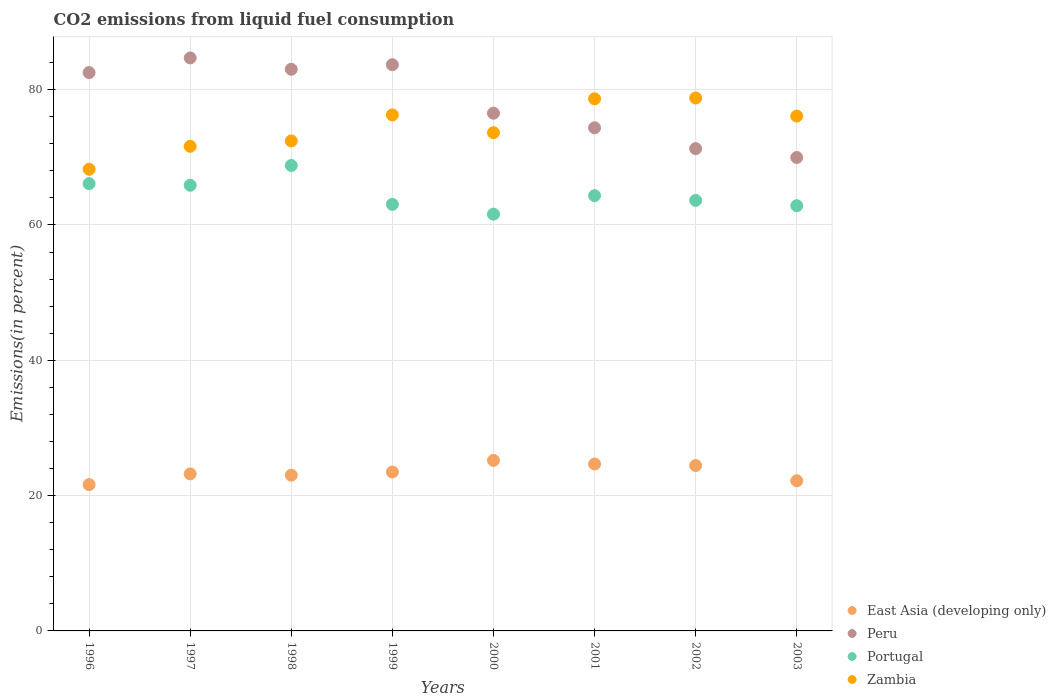What is the total CO2 emitted in Zambia in 1997?
Make the answer very short. 71.63. Across all years, what is the maximum total CO2 emitted in Zambia?
Give a very brief answer. 78.77. Across all years, what is the minimum total CO2 emitted in East Asia (developing only)?
Make the answer very short. 21.63. In which year was the total CO2 emitted in Zambia maximum?
Provide a short and direct response. 2002. What is the total total CO2 emitted in Zambia in the graph?
Your answer should be compact. 595.71. What is the difference between the total CO2 emitted in Peru in 1996 and that in 2001?
Ensure brevity in your answer.  8.16. What is the difference between the total CO2 emitted in Portugal in 1998 and the total CO2 emitted in Zambia in 1996?
Give a very brief answer. 0.56. What is the average total CO2 emitted in Peru per year?
Ensure brevity in your answer.  78.26. In the year 2000, what is the difference between the total CO2 emitted in East Asia (developing only) and total CO2 emitted in Portugal?
Ensure brevity in your answer.  -36.39. In how many years, is the total CO2 emitted in Peru greater than 24 %?
Make the answer very short. 8. What is the ratio of the total CO2 emitted in East Asia (developing only) in 1996 to that in 2003?
Ensure brevity in your answer.  0.97. Is the total CO2 emitted in Peru in 1996 less than that in 1998?
Your answer should be compact. Yes. What is the difference between the highest and the second highest total CO2 emitted in Portugal?
Offer a very short reply. 2.68. What is the difference between the highest and the lowest total CO2 emitted in East Asia (developing only)?
Give a very brief answer. 3.58. What is the difference between two consecutive major ticks on the Y-axis?
Give a very brief answer. 20. Does the graph contain any zero values?
Ensure brevity in your answer.  No. Does the graph contain grids?
Ensure brevity in your answer.  Yes. How are the legend labels stacked?
Offer a very short reply. Vertical. What is the title of the graph?
Offer a terse response. CO2 emissions from liquid fuel consumption. Does "Bhutan" appear as one of the legend labels in the graph?
Provide a succinct answer. No. What is the label or title of the X-axis?
Make the answer very short. Years. What is the label or title of the Y-axis?
Keep it short and to the point. Emissions(in percent). What is the Emissions(in percent) of East Asia (developing only) in 1996?
Ensure brevity in your answer.  21.63. What is the Emissions(in percent) in Peru in 1996?
Offer a very short reply. 82.53. What is the Emissions(in percent) in Portugal in 1996?
Offer a terse response. 66.11. What is the Emissions(in percent) of Zambia in 1996?
Provide a succinct answer. 68.24. What is the Emissions(in percent) in East Asia (developing only) in 1997?
Your response must be concise. 23.21. What is the Emissions(in percent) of Peru in 1997?
Provide a short and direct response. 84.69. What is the Emissions(in percent) of Portugal in 1997?
Your answer should be compact. 65.87. What is the Emissions(in percent) in Zambia in 1997?
Provide a short and direct response. 71.63. What is the Emissions(in percent) of East Asia (developing only) in 1998?
Your response must be concise. 23.02. What is the Emissions(in percent) of Peru in 1998?
Provide a short and direct response. 83.01. What is the Emissions(in percent) in Portugal in 1998?
Your response must be concise. 68.79. What is the Emissions(in percent) of Zambia in 1998?
Ensure brevity in your answer.  72.42. What is the Emissions(in percent) of East Asia (developing only) in 1999?
Offer a terse response. 23.49. What is the Emissions(in percent) in Peru in 1999?
Provide a short and direct response. 83.69. What is the Emissions(in percent) in Portugal in 1999?
Ensure brevity in your answer.  63.05. What is the Emissions(in percent) in Zambia in 1999?
Your response must be concise. 76.27. What is the Emissions(in percent) of East Asia (developing only) in 2000?
Give a very brief answer. 25.21. What is the Emissions(in percent) in Peru in 2000?
Offer a terse response. 76.52. What is the Emissions(in percent) of Portugal in 2000?
Offer a very short reply. 61.6. What is the Emissions(in percent) of Zambia in 2000?
Your response must be concise. 73.64. What is the Emissions(in percent) of East Asia (developing only) in 2001?
Keep it short and to the point. 24.67. What is the Emissions(in percent) in Peru in 2001?
Give a very brief answer. 74.37. What is the Emissions(in percent) of Portugal in 2001?
Keep it short and to the point. 64.34. What is the Emissions(in percent) of Zambia in 2001?
Ensure brevity in your answer.  78.65. What is the Emissions(in percent) of East Asia (developing only) in 2002?
Your response must be concise. 24.45. What is the Emissions(in percent) of Peru in 2002?
Ensure brevity in your answer.  71.28. What is the Emissions(in percent) in Portugal in 2002?
Your response must be concise. 63.63. What is the Emissions(in percent) in Zambia in 2002?
Your response must be concise. 78.77. What is the Emissions(in percent) in East Asia (developing only) in 2003?
Make the answer very short. 22.19. What is the Emissions(in percent) of Peru in 2003?
Give a very brief answer. 69.97. What is the Emissions(in percent) in Portugal in 2003?
Give a very brief answer. 62.85. What is the Emissions(in percent) of Zambia in 2003?
Keep it short and to the point. 76.09. Across all years, what is the maximum Emissions(in percent) of East Asia (developing only)?
Provide a short and direct response. 25.21. Across all years, what is the maximum Emissions(in percent) of Peru?
Your response must be concise. 84.69. Across all years, what is the maximum Emissions(in percent) of Portugal?
Provide a succinct answer. 68.79. Across all years, what is the maximum Emissions(in percent) of Zambia?
Offer a very short reply. 78.77. Across all years, what is the minimum Emissions(in percent) in East Asia (developing only)?
Your answer should be compact. 21.63. Across all years, what is the minimum Emissions(in percent) in Peru?
Give a very brief answer. 69.97. Across all years, what is the minimum Emissions(in percent) of Portugal?
Give a very brief answer. 61.6. Across all years, what is the minimum Emissions(in percent) in Zambia?
Provide a short and direct response. 68.24. What is the total Emissions(in percent) of East Asia (developing only) in the graph?
Make the answer very short. 187.87. What is the total Emissions(in percent) in Peru in the graph?
Offer a terse response. 626.06. What is the total Emissions(in percent) of Portugal in the graph?
Offer a terse response. 516.23. What is the total Emissions(in percent) in Zambia in the graph?
Offer a terse response. 595.71. What is the difference between the Emissions(in percent) of East Asia (developing only) in 1996 and that in 1997?
Your response must be concise. -1.58. What is the difference between the Emissions(in percent) of Peru in 1996 and that in 1997?
Give a very brief answer. -2.17. What is the difference between the Emissions(in percent) of Portugal in 1996 and that in 1997?
Your answer should be compact. 0.24. What is the difference between the Emissions(in percent) in Zambia in 1996 and that in 1997?
Offer a very short reply. -3.39. What is the difference between the Emissions(in percent) in East Asia (developing only) in 1996 and that in 1998?
Your response must be concise. -1.39. What is the difference between the Emissions(in percent) of Peru in 1996 and that in 1998?
Ensure brevity in your answer.  -0.49. What is the difference between the Emissions(in percent) in Portugal in 1996 and that in 1998?
Ensure brevity in your answer.  -2.68. What is the difference between the Emissions(in percent) in Zambia in 1996 and that in 1998?
Your response must be concise. -4.19. What is the difference between the Emissions(in percent) of East Asia (developing only) in 1996 and that in 1999?
Give a very brief answer. -1.86. What is the difference between the Emissions(in percent) in Peru in 1996 and that in 1999?
Provide a short and direct response. -1.16. What is the difference between the Emissions(in percent) of Portugal in 1996 and that in 1999?
Keep it short and to the point. 3.06. What is the difference between the Emissions(in percent) of Zambia in 1996 and that in 1999?
Ensure brevity in your answer.  -8.03. What is the difference between the Emissions(in percent) of East Asia (developing only) in 1996 and that in 2000?
Offer a very short reply. -3.58. What is the difference between the Emissions(in percent) of Peru in 1996 and that in 2000?
Your response must be concise. 6.01. What is the difference between the Emissions(in percent) in Portugal in 1996 and that in 2000?
Your answer should be compact. 4.51. What is the difference between the Emissions(in percent) in Zambia in 1996 and that in 2000?
Keep it short and to the point. -5.41. What is the difference between the Emissions(in percent) in East Asia (developing only) in 1996 and that in 2001?
Give a very brief answer. -3.04. What is the difference between the Emissions(in percent) of Peru in 1996 and that in 2001?
Your answer should be compact. 8.16. What is the difference between the Emissions(in percent) of Portugal in 1996 and that in 2001?
Keep it short and to the point. 1.77. What is the difference between the Emissions(in percent) of Zambia in 1996 and that in 2001?
Offer a very short reply. -10.42. What is the difference between the Emissions(in percent) of East Asia (developing only) in 1996 and that in 2002?
Give a very brief answer. -2.82. What is the difference between the Emissions(in percent) of Peru in 1996 and that in 2002?
Ensure brevity in your answer.  11.24. What is the difference between the Emissions(in percent) of Portugal in 1996 and that in 2002?
Give a very brief answer. 2.48. What is the difference between the Emissions(in percent) in Zambia in 1996 and that in 2002?
Ensure brevity in your answer.  -10.54. What is the difference between the Emissions(in percent) of East Asia (developing only) in 1996 and that in 2003?
Offer a very short reply. -0.56. What is the difference between the Emissions(in percent) of Peru in 1996 and that in 2003?
Ensure brevity in your answer.  12.55. What is the difference between the Emissions(in percent) in Portugal in 1996 and that in 2003?
Keep it short and to the point. 3.26. What is the difference between the Emissions(in percent) in Zambia in 1996 and that in 2003?
Offer a terse response. -7.86. What is the difference between the Emissions(in percent) in East Asia (developing only) in 1997 and that in 1998?
Offer a very short reply. 0.19. What is the difference between the Emissions(in percent) in Peru in 1997 and that in 1998?
Your answer should be compact. 1.68. What is the difference between the Emissions(in percent) of Portugal in 1997 and that in 1998?
Keep it short and to the point. -2.92. What is the difference between the Emissions(in percent) of Zambia in 1997 and that in 1998?
Keep it short and to the point. -0.8. What is the difference between the Emissions(in percent) in East Asia (developing only) in 1997 and that in 1999?
Ensure brevity in your answer.  -0.28. What is the difference between the Emissions(in percent) of Peru in 1997 and that in 1999?
Offer a terse response. 1.01. What is the difference between the Emissions(in percent) in Portugal in 1997 and that in 1999?
Your answer should be very brief. 2.82. What is the difference between the Emissions(in percent) of Zambia in 1997 and that in 1999?
Make the answer very short. -4.64. What is the difference between the Emissions(in percent) in East Asia (developing only) in 1997 and that in 2000?
Keep it short and to the point. -1.99. What is the difference between the Emissions(in percent) of Peru in 1997 and that in 2000?
Make the answer very short. 8.17. What is the difference between the Emissions(in percent) in Portugal in 1997 and that in 2000?
Provide a succinct answer. 4.27. What is the difference between the Emissions(in percent) in Zambia in 1997 and that in 2000?
Ensure brevity in your answer.  -2.02. What is the difference between the Emissions(in percent) in East Asia (developing only) in 1997 and that in 2001?
Make the answer very short. -1.46. What is the difference between the Emissions(in percent) of Peru in 1997 and that in 2001?
Make the answer very short. 10.33. What is the difference between the Emissions(in percent) in Portugal in 1997 and that in 2001?
Your answer should be very brief. 1.53. What is the difference between the Emissions(in percent) in Zambia in 1997 and that in 2001?
Ensure brevity in your answer.  -7.03. What is the difference between the Emissions(in percent) of East Asia (developing only) in 1997 and that in 2002?
Make the answer very short. -1.24. What is the difference between the Emissions(in percent) in Peru in 1997 and that in 2002?
Offer a very short reply. 13.41. What is the difference between the Emissions(in percent) of Portugal in 1997 and that in 2002?
Offer a very short reply. 2.24. What is the difference between the Emissions(in percent) of Zambia in 1997 and that in 2002?
Make the answer very short. -7.15. What is the difference between the Emissions(in percent) of East Asia (developing only) in 1997 and that in 2003?
Offer a terse response. 1.02. What is the difference between the Emissions(in percent) in Peru in 1997 and that in 2003?
Give a very brief answer. 14.72. What is the difference between the Emissions(in percent) in Portugal in 1997 and that in 2003?
Provide a succinct answer. 3.02. What is the difference between the Emissions(in percent) of Zambia in 1997 and that in 2003?
Keep it short and to the point. -4.46. What is the difference between the Emissions(in percent) in East Asia (developing only) in 1998 and that in 1999?
Offer a terse response. -0.47. What is the difference between the Emissions(in percent) of Peru in 1998 and that in 1999?
Provide a short and direct response. -0.67. What is the difference between the Emissions(in percent) of Portugal in 1998 and that in 1999?
Offer a very short reply. 5.74. What is the difference between the Emissions(in percent) in Zambia in 1998 and that in 1999?
Provide a succinct answer. -3.84. What is the difference between the Emissions(in percent) of East Asia (developing only) in 1998 and that in 2000?
Your answer should be very brief. -2.19. What is the difference between the Emissions(in percent) in Peru in 1998 and that in 2000?
Your answer should be very brief. 6.5. What is the difference between the Emissions(in percent) of Portugal in 1998 and that in 2000?
Keep it short and to the point. 7.19. What is the difference between the Emissions(in percent) in Zambia in 1998 and that in 2000?
Your answer should be very brief. -1.22. What is the difference between the Emissions(in percent) in East Asia (developing only) in 1998 and that in 2001?
Keep it short and to the point. -1.65. What is the difference between the Emissions(in percent) of Peru in 1998 and that in 2001?
Make the answer very short. 8.65. What is the difference between the Emissions(in percent) in Portugal in 1998 and that in 2001?
Provide a succinct answer. 4.46. What is the difference between the Emissions(in percent) of Zambia in 1998 and that in 2001?
Ensure brevity in your answer.  -6.23. What is the difference between the Emissions(in percent) in East Asia (developing only) in 1998 and that in 2002?
Your answer should be compact. -1.43. What is the difference between the Emissions(in percent) of Peru in 1998 and that in 2002?
Ensure brevity in your answer.  11.73. What is the difference between the Emissions(in percent) in Portugal in 1998 and that in 2002?
Your answer should be very brief. 5.16. What is the difference between the Emissions(in percent) in Zambia in 1998 and that in 2002?
Offer a very short reply. -6.35. What is the difference between the Emissions(in percent) of East Asia (developing only) in 1998 and that in 2003?
Ensure brevity in your answer.  0.83. What is the difference between the Emissions(in percent) in Peru in 1998 and that in 2003?
Your response must be concise. 13.04. What is the difference between the Emissions(in percent) in Portugal in 1998 and that in 2003?
Your response must be concise. 5.94. What is the difference between the Emissions(in percent) in Zambia in 1998 and that in 2003?
Keep it short and to the point. -3.67. What is the difference between the Emissions(in percent) in East Asia (developing only) in 1999 and that in 2000?
Make the answer very short. -1.72. What is the difference between the Emissions(in percent) in Peru in 1999 and that in 2000?
Provide a short and direct response. 7.17. What is the difference between the Emissions(in percent) in Portugal in 1999 and that in 2000?
Give a very brief answer. 1.45. What is the difference between the Emissions(in percent) of Zambia in 1999 and that in 2000?
Your answer should be very brief. 2.63. What is the difference between the Emissions(in percent) in East Asia (developing only) in 1999 and that in 2001?
Your response must be concise. -1.18. What is the difference between the Emissions(in percent) in Peru in 1999 and that in 2001?
Offer a very short reply. 9.32. What is the difference between the Emissions(in percent) in Portugal in 1999 and that in 2001?
Keep it short and to the point. -1.29. What is the difference between the Emissions(in percent) in Zambia in 1999 and that in 2001?
Offer a very short reply. -2.39. What is the difference between the Emissions(in percent) in East Asia (developing only) in 1999 and that in 2002?
Give a very brief answer. -0.96. What is the difference between the Emissions(in percent) in Peru in 1999 and that in 2002?
Your answer should be compact. 12.4. What is the difference between the Emissions(in percent) in Portugal in 1999 and that in 2002?
Make the answer very short. -0.59. What is the difference between the Emissions(in percent) in Zambia in 1999 and that in 2002?
Make the answer very short. -2.5. What is the difference between the Emissions(in percent) in East Asia (developing only) in 1999 and that in 2003?
Keep it short and to the point. 1.3. What is the difference between the Emissions(in percent) of Peru in 1999 and that in 2003?
Provide a short and direct response. 13.71. What is the difference between the Emissions(in percent) in Portugal in 1999 and that in 2003?
Give a very brief answer. 0.2. What is the difference between the Emissions(in percent) of Zambia in 1999 and that in 2003?
Your response must be concise. 0.18. What is the difference between the Emissions(in percent) in East Asia (developing only) in 2000 and that in 2001?
Keep it short and to the point. 0.53. What is the difference between the Emissions(in percent) of Peru in 2000 and that in 2001?
Your answer should be very brief. 2.15. What is the difference between the Emissions(in percent) in Portugal in 2000 and that in 2001?
Your response must be concise. -2.74. What is the difference between the Emissions(in percent) in Zambia in 2000 and that in 2001?
Your answer should be very brief. -5.01. What is the difference between the Emissions(in percent) of East Asia (developing only) in 2000 and that in 2002?
Give a very brief answer. 0.76. What is the difference between the Emissions(in percent) in Peru in 2000 and that in 2002?
Your response must be concise. 5.23. What is the difference between the Emissions(in percent) of Portugal in 2000 and that in 2002?
Ensure brevity in your answer.  -2.03. What is the difference between the Emissions(in percent) of Zambia in 2000 and that in 2002?
Provide a short and direct response. -5.13. What is the difference between the Emissions(in percent) of East Asia (developing only) in 2000 and that in 2003?
Give a very brief answer. 3.01. What is the difference between the Emissions(in percent) of Peru in 2000 and that in 2003?
Ensure brevity in your answer.  6.54. What is the difference between the Emissions(in percent) in Portugal in 2000 and that in 2003?
Offer a terse response. -1.25. What is the difference between the Emissions(in percent) in Zambia in 2000 and that in 2003?
Your response must be concise. -2.45. What is the difference between the Emissions(in percent) in East Asia (developing only) in 2001 and that in 2002?
Your response must be concise. 0.22. What is the difference between the Emissions(in percent) in Peru in 2001 and that in 2002?
Offer a very short reply. 3.08. What is the difference between the Emissions(in percent) of Portugal in 2001 and that in 2002?
Provide a succinct answer. 0.7. What is the difference between the Emissions(in percent) in Zambia in 2001 and that in 2002?
Your answer should be compact. -0.12. What is the difference between the Emissions(in percent) in East Asia (developing only) in 2001 and that in 2003?
Your response must be concise. 2.48. What is the difference between the Emissions(in percent) of Peru in 2001 and that in 2003?
Provide a succinct answer. 4.39. What is the difference between the Emissions(in percent) of Portugal in 2001 and that in 2003?
Offer a terse response. 1.49. What is the difference between the Emissions(in percent) in Zambia in 2001 and that in 2003?
Give a very brief answer. 2.56. What is the difference between the Emissions(in percent) of East Asia (developing only) in 2002 and that in 2003?
Ensure brevity in your answer.  2.26. What is the difference between the Emissions(in percent) in Peru in 2002 and that in 2003?
Your response must be concise. 1.31. What is the difference between the Emissions(in percent) of Portugal in 2002 and that in 2003?
Offer a terse response. 0.78. What is the difference between the Emissions(in percent) of Zambia in 2002 and that in 2003?
Provide a short and direct response. 2.68. What is the difference between the Emissions(in percent) in East Asia (developing only) in 1996 and the Emissions(in percent) in Peru in 1997?
Your answer should be compact. -63.07. What is the difference between the Emissions(in percent) in East Asia (developing only) in 1996 and the Emissions(in percent) in Portugal in 1997?
Provide a short and direct response. -44.24. What is the difference between the Emissions(in percent) in East Asia (developing only) in 1996 and the Emissions(in percent) in Zambia in 1997?
Make the answer very short. -50. What is the difference between the Emissions(in percent) of Peru in 1996 and the Emissions(in percent) of Portugal in 1997?
Provide a succinct answer. 16.66. What is the difference between the Emissions(in percent) of Peru in 1996 and the Emissions(in percent) of Zambia in 1997?
Your answer should be compact. 10.9. What is the difference between the Emissions(in percent) of Portugal in 1996 and the Emissions(in percent) of Zambia in 1997?
Your answer should be very brief. -5.52. What is the difference between the Emissions(in percent) of East Asia (developing only) in 1996 and the Emissions(in percent) of Peru in 1998?
Provide a short and direct response. -61.39. What is the difference between the Emissions(in percent) of East Asia (developing only) in 1996 and the Emissions(in percent) of Portugal in 1998?
Provide a succinct answer. -47.16. What is the difference between the Emissions(in percent) of East Asia (developing only) in 1996 and the Emissions(in percent) of Zambia in 1998?
Give a very brief answer. -50.8. What is the difference between the Emissions(in percent) in Peru in 1996 and the Emissions(in percent) in Portugal in 1998?
Make the answer very short. 13.73. What is the difference between the Emissions(in percent) of Peru in 1996 and the Emissions(in percent) of Zambia in 1998?
Your response must be concise. 10.1. What is the difference between the Emissions(in percent) of Portugal in 1996 and the Emissions(in percent) of Zambia in 1998?
Your answer should be compact. -6.32. What is the difference between the Emissions(in percent) in East Asia (developing only) in 1996 and the Emissions(in percent) in Peru in 1999?
Your answer should be very brief. -62.06. What is the difference between the Emissions(in percent) of East Asia (developing only) in 1996 and the Emissions(in percent) of Portugal in 1999?
Your answer should be compact. -41.42. What is the difference between the Emissions(in percent) of East Asia (developing only) in 1996 and the Emissions(in percent) of Zambia in 1999?
Keep it short and to the point. -54.64. What is the difference between the Emissions(in percent) in Peru in 1996 and the Emissions(in percent) in Portugal in 1999?
Give a very brief answer. 19.48. What is the difference between the Emissions(in percent) of Peru in 1996 and the Emissions(in percent) of Zambia in 1999?
Provide a short and direct response. 6.26. What is the difference between the Emissions(in percent) in Portugal in 1996 and the Emissions(in percent) in Zambia in 1999?
Keep it short and to the point. -10.16. What is the difference between the Emissions(in percent) of East Asia (developing only) in 1996 and the Emissions(in percent) of Peru in 2000?
Give a very brief answer. -54.89. What is the difference between the Emissions(in percent) of East Asia (developing only) in 1996 and the Emissions(in percent) of Portugal in 2000?
Keep it short and to the point. -39.97. What is the difference between the Emissions(in percent) of East Asia (developing only) in 1996 and the Emissions(in percent) of Zambia in 2000?
Make the answer very short. -52.01. What is the difference between the Emissions(in percent) of Peru in 1996 and the Emissions(in percent) of Portugal in 2000?
Keep it short and to the point. 20.93. What is the difference between the Emissions(in percent) in Peru in 1996 and the Emissions(in percent) in Zambia in 2000?
Your response must be concise. 8.88. What is the difference between the Emissions(in percent) of Portugal in 1996 and the Emissions(in percent) of Zambia in 2000?
Offer a very short reply. -7.53. What is the difference between the Emissions(in percent) of East Asia (developing only) in 1996 and the Emissions(in percent) of Peru in 2001?
Give a very brief answer. -52.74. What is the difference between the Emissions(in percent) of East Asia (developing only) in 1996 and the Emissions(in percent) of Portugal in 2001?
Give a very brief answer. -42.71. What is the difference between the Emissions(in percent) in East Asia (developing only) in 1996 and the Emissions(in percent) in Zambia in 2001?
Your answer should be very brief. -57.03. What is the difference between the Emissions(in percent) of Peru in 1996 and the Emissions(in percent) of Portugal in 2001?
Provide a succinct answer. 18.19. What is the difference between the Emissions(in percent) in Peru in 1996 and the Emissions(in percent) in Zambia in 2001?
Ensure brevity in your answer.  3.87. What is the difference between the Emissions(in percent) in Portugal in 1996 and the Emissions(in percent) in Zambia in 2001?
Your response must be concise. -12.55. What is the difference between the Emissions(in percent) in East Asia (developing only) in 1996 and the Emissions(in percent) in Peru in 2002?
Offer a very short reply. -49.66. What is the difference between the Emissions(in percent) of East Asia (developing only) in 1996 and the Emissions(in percent) of Portugal in 2002?
Ensure brevity in your answer.  -42. What is the difference between the Emissions(in percent) in East Asia (developing only) in 1996 and the Emissions(in percent) in Zambia in 2002?
Your answer should be very brief. -57.14. What is the difference between the Emissions(in percent) in Peru in 1996 and the Emissions(in percent) in Portugal in 2002?
Provide a short and direct response. 18.89. What is the difference between the Emissions(in percent) of Peru in 1996 and the Emissions(in percent) of Zambia in 2002?
Provide a succinct answer. 3.75. What is the difference between the Emissions(in percent) of Portugal in 1996 and the Emissions(in percent) of Zambia in 2002?
Your answer should be very brief. -12.66. What is the difference between the Emissions(in percent) in East Asia (developing only) in 1996 and the Emissions(in percent) in Peru in 2003?
Offer a very short reply. -48.35. What is the difference between the Emissions(in percent) of East Asia (developing only) in 1996 and the Emissions(in percent) of Portugal in 2003?
Your answer should be very brief. -41.22. What is the difference between the Emissions(in percent) in East Asia (developing only) in 1996 and the Emissions(in percent) in Zambia in 2003?
Provide a succinct answer. -54.46. What is the difference between the Emissions(in percent) in Peru in 1996 and the Emissions(in percent) in Portugal in 2003?
Make the answer very short. 19.68. What is the difference between the Emissions(in percent) in Peru in 1996 and the Emissions(in percent) in Zambia in 2003?
Provide a short and direct response. 6.43. What is the difference between the Emissions(in percent) of Portugal in 1996 and the Emissions(in percent) of Zambia in 2003?
Your response must be concise. -9.98. What is the difference between the Emissions(in percent) in East Asia (developing only) in 1997 and the Emissions(in percent) in Peru in 1998?
Your response must be concise. -59.8. What is the difference between the Emissions(in percent) in East Asia (developing only) in 1997 and the Emissions(in percent) in Portugal in 1998?
Keep it short and to the point. -45.58. What is the difference between the Emissions(in percent) in East Asia (developing only) in 1997 and the Emissions(in percent) in Zambia in 1998?
Your answer should be compact. -49.21. What is the difference between the Emissions(in percent) in Peru in 1997 and the Emissions(in percent) in Portugal in 1998?
Keep it short and to the point. 15.9. What is the difference between the Emissions(in percent) in Peru in 1997 and the Emissions(in percent) in Zambia in 1998?
Keep it short and to the point. 12.27. What is the difference between the Emissions(in percent) in Portugal in 1997 and the Emissions(in percent) in Zambia in 1998?
Your answer should be compact. -6.56. What is the difference between the Emissions(in percent) of East Asia (developing only) in 1997 and the Emissions(in percent) of Peru in 1999?
Offer a very short reply. -60.47. What is the difference between the Emissions(in percent) in East Asia (developing only) in 1997 and the Emissions(in percent) in Portugal in 1999?
Your answer should be compact. -39.83. What is the difference between the Emissions(in percent) in East Asia (developing only) in 1997 and the Emissions(in percent) in Zambia in 1999?
Keep it short and to the point. -53.06. What is the difference between the Emissions(in percent) in Peru in 1997 and the Emissions(in percent) in Portugal in 1999?
Your response must be concise. 21.65. What is the difference between the Emissions(in percent) of Peru in 1997 and the Emissions(in percent) of Zambia in 1999?
Provide a short and direct response. 8.43. What is the difference between the Emissions(in percent) of Portugal in 1997 and the Emissions(in percent) of Zambia in 1999?
Ensure brevity in your answer.  -10.4. What is the difference between the Emissions(in percent) of East Asia (developing only) in 1997 and the Emissions(in percent) of Peru in 2000?
Give a very brief answer. -53.31. What is the difference between the Emissions(in percent) in East Asia (developing only) in 1997 and the Emissions(in percent) in Portugal in 2000?
Your answer should be very brief. -38.39. What is the difference between the Emissions(in percent) of East Asia (developing only) in 1997 and the Emissions(in percent) of Zambia in 2000?
Offer a very short reply. -50.43. What is the difference between the Emissions(in percent) of Peru in 1997 and the Emissions(in percent) of Portugal in 2000?
Ensure brevity in your answer.  23.1. What is the difference between the Emissions(in percent) in Peru in 1997 and the Emissions(in percent) in Zambia in 2000?
Ensure brevity in your answer.  11.05. What is the difference between the Emissions(in percent) in Portugal in 1997 and the Emissions(in percent) in Zambia in 2000?
Give a very brief answer. -7.77. What is the difference between the Emissions(in percent) in East Asia (developing only) in 1997 and the Emissions(in percent) in Peru in 2001?
Your answer should be compact. -51.15. What is the difference between the Emissions(in percent) in East Asia (developing only) in 1997 and the Emissions(in percent) in Portugal in 2001?
Offer a terse response. -41.12. What is the difference between the Emissions(in percent) in East Asia (developing only) in 1997 and the Emissions(in percent) in Zambia in 2001?
Make the answer very short. -55.44. What is the difference between the Emissions(in percent) in Peru in 1997 and the Emissions(in percent) in Portugal in 2001?
Offer a terse response. 20.36. What is the difference between the Emissions(in percent) of Peru in 1997 and the Emissions(in percent) of Zambia in 2001?
Your response must be concise. 6.04. What is the difference between the Emissions(in percent) of Portugal in 1997 and the Emissions(in percent) of Zambia in 2001?
Ensure brevity in your answer.  -12.79. What is the difference between the Emissions(in percent) in East Asia (developing only) in 1997 and the Emissions(in percent) in Peru in 2002?
Keep it short and to the point. -48.07. What is the difference between the Emissions(in percent) in East Asia (developing only) in 1997 and the Emissions(in percent) in Portugal in 2002?
Provide a succinct answer. -40.42. What is the difference between the Emissions(in percent) of East Asia (developing only) in 1997 and the Emissions(in percent) of Zambia in 2002?
Your answer should be very brief. -55.56. What is the difference between the Emissions(in percent) of Peru in 1997 and the Emissions(in percent) of Portugal in 2002?
Provide a short and direct response. 21.06. What is the difference between the Emissions(in percent) of Peru in 1997 and the Emissions(in percent) of Zambia in 2002?
Provide a succinct answer. 5.92. What is the difference between the Emissions(in percent) in Portugal in 1997 and the Emissions(in percent) in Zambia in 2002?
Your response must be concise. -12.9. What is the difference between the Emissions(in percent) in East Asia (developing only) in 1997 and the Emissions(in percent) in Peru in 2003?
Offer a terse response. -46.76. What is the difference between the Emissions(in percent) of East Asia (developing only) in 1997 and the Emissions(in percent) of Portugal in 2003?
Your answer should be compact. -39.64. What is the difference between the Emissions(in percent) of East Asia (developing only) in 1997 and the Emissions(in percent) of Zambia in 2003?
Give a very brief answer. -52.88. What is the difference between the Emissions(in percent) of Peru in 1997 and the Emissions(in percent) of Portugal in 2003?
Ensure brevity in your answer.  21.84. What is the difference between the Emissions(in percent) of Peru in 1997 and the Emissions(in percent) of Zambia in 2003?
Provide a short and direct response. 8.6. What is the difference between the Emissions(in percent) of Portugal in 1997 and the Emissions(in percent) of Zambia in 2003?
Ensure brevity in your answer.  -10.22. What is the difference between the Emissions(in percent) in East Asia (developing only) in 1998 and the Emissions(in percent) in Peru in 1999?
Give a very brief answer. -60.67. What is the difference between the Emissions(in percent) in East Asia (developing only) in 1998 and the Emissions(in percent) in Portugal in 1999?
Provide a succinct answer. -40.03. What is the difference between the Emissions(in percent) of East Asia (developing only) in 1998 and the Emissions(in percent) of Zambia in 1999?
Keep it short and to the point. -53.25. What is the difference between the Emissions(in percent) in Peru in 1998 and the Emissions(in percent) in Portugal in 1999?
Give a very brief answer. 19.97. What is the difference between the Emissions(in percent) in Peru in 1998 and the Emissions(in percent) in Zambia in 1999?
Provide a short and direct response. 6.75. What is the difference between the Emissions(in percent) of Portugal in 1998 and the Emissions(in percent) of Zambia in 1999?
Offer a very short reply. -7.48. What is the difference between the Emissions(in percent) in East Asia (developing only) in 1998 and the Emissions(in percent) in Peru in 2000?
Your answer should be very brief. -53.5. What is the difference between the Emissions(in percent) in East Asia (developing only) in 1998 and the Emissions(in percent) in Portugal in 2000?
Your answer should be very brief. -38.58. What is the difference between the Emissions(in percent) in East Asia (developing only) in 1998 and the Emissions(in percent) in Zambia in 2000?
Your answer should be compact. -50.62. What is the difference between the Emissions(in percent) of Peru in 1998 and the Emissions(in percent) of Portugal in 2000?
Offer a very short reply. 21.42. What is the difference between the Emissions(in percent) in Peru in 1998 and the Emissions(in percent) in Zambia in 2000?
Give a very brief answer. 9.37. What is the difference between the Emissions(in percent) of Portugal in 1998 and the Emissions(in percent) of Zambia in 2000?
Offer a terse response. -4.85. What is the difference between the Emissions(in percent) in East Asia (developing only) in 1998 and the Emissions(in percent) in Peru in 2001?
Offer a very short reply. -51.35. What is the difference between the Emissions(in percent) of East Asia (developing only) in 1998 and the Emissions(in percent) of Portugal in 2001?
Ensure brevity in your answer.  -41.32. What is the difference between the Emissions(in percent) in East Asia (developing only) in 1998 and the Emissions(in percent) in Zambia in 2001?
Offer a very short reply. -55.63. What is the difference between the Emissions(in percent) of Peru in 1998 and the Emissions(in percent) of Portugal in 2001?
Give a very brief answer. 18.68. What is the difference between the Emissions(in percent) of Peru in 1998 and the Emissions(in percent) of Zambia in 2001?
Your answer should be compact. 4.36. What is the difference between the Emissions(in percent) of Portugal in 1998 and the Emissions(in percent) of Zambia in 2001?
Your response must be concise. -9.86. What is the difference between the Emissions(in percent) in East Asia (developing only) in 1998 and the Emissions(in percent) in Peru in 2002?
Provide a succinct answer. -48.26. What is the difference between the Emissions(in percent) of East Asia (developing only) in 1998 and the Emissions(in percent) of Portugal in 2002?
Your answer should be very brief. -40.61. What is the difference between the Emissions(in percent) in East Asia (developing only) in 1998 and the Emissions(in percent) in Zambia in 2002?
Keep it short and to the point. -55.75. What is the difference between the Emissions(in percent) of Peru in 1998 and the Emissions(in percent) of Portugal in 2002?
Ensure brevity in your answer.  19.38. What is the difference between the Emissions(in percent) in Peru in 1998 and the Emissions(in percent) in Zambia in 2002?
Your response must be concise. 4.24. What is the difference between the Emissions(in percent) of Portugal in 1998 and the Emissions(in percent) of Zambia in 2002?
Your answer should be very brief. -9.98. What is the difference between the Emissions(in percent) of East Asia (developing only) in 1998 and the Emissions(in percent) of Peru in 2003?
Your response must be concise. -46.96. What is the difference between the Emissions(in percent) in East Asia (developing only) in 1998 and the Emissions(in percent) in Portugal in 2003?
Provide a succinct answer. -39.83. What is the difference between the Emissions(in percent) of East Asia (developing only) in 1998 and the Emissions(in percent) of Zambia in 2003?
Make the answer very short. -53.07. What is the difference between the Emissions(in percent) of Peru in 1998 and the Emissions(in percent) of Portugal in 2003?
Offer a very short reply. 20.17. What is the difference between the Emissions(in percent) of Peru in 1998 and the Emissions(in percent) of Zambia in 2003?
Your response must be concise. 6.92. What is the difference between the Emissions(in percent) of Portugal in 1998 and the Emissions(in percent) of Zambia in 2003?
Make the answer very short. -7.3. What is the difference between the Emissions(in percent) in East Asia (developing only) in 1999 and the Emissions(in percent) in Peru in 2000?
Make the answer very short. -53.03. What is the difference between the Emissions(in percent) of East Asia (developing only) in 1999 and the Emissions(in percent) of Portugal in 2000?
Provide a succinct answer. -38.11. What is the difference between the Emissions(in percent) in East Asia (developing only) in 1999 and the Emissions(in percent) in Zambia in 2000?
Your answer should be very brief. -50.15. What is the difference between the Emissions(in percent) in Peru in 1999 and the Emissions(in percent) in Portugal in 2000?
Your response must be concise. 22.09. What is the difference between the Emissions(in percent) in Peru in 1999 and the Emissions(in percent) in Zambia in 2000?
Your answer should be very brief. 10.05. What is the difference between the Emissions(in percent) of Portugal in 1999 and the Emissions(in percent) of Zambia in 2000?
Ensure brevity in your answer.  -10.6. What is the difference between the Emissions(in percent) in East Asia (developing only) in 1999 and the Emissions(in percent) in Peru in 2001?
Provide a short and direct response. -50.88. What is the difference between the Emissions(in percent) of East Asia (developing only) in 1999 and the Emissions(in percent) of Portugal in 2001?
Your answer should be compact. -40.85. What is the difference between the Emissions(in percent) of East Asia (developing only) in 1999 and the Emissions(in percent) of Zambia in 2001?
Your answer should be compact. -55.16. What is the difference between the Emissions(in percent) in Peru in 1999 and the Emissions(in percent) in Portugal in 2001?
Keep it short and to the point. 19.35. What is the difference between the Emissions(in percent) of Peru in 1999 and the Emissions(in percent) of Zambia in 2001?
Provide a succinct answer. 5.03. What is the difference between the Emissions(in percent) of Portugal in 1999 and the Emissions(in percent) of Zambia in 2001?
Ensure brevity in your answer.  -15.61. What is the difference between the Emissions(in percent) in East Asia (developing only) in 1999 and the Emissions(in percent) in Peru in 2002?
Provide a succinct answer. -47.79. What is the difference between the Emissions(in percent) of East Asia (developing only) in 1999 and the Emissions(in percent) of Portugal in 2002?
Provide a succinct answer. -40.14. What is the difference between the Emissions(in percent) in East Asia (developing only) in 1999 and the Emissions(in percent) in Zambia in 2002?
Provide a succinct answer. -55.28. What is the difference between the Emissions(in percent) of Peru in 1999 and the Emissions(in percent) of Portugal in 2002?
Offer a terse response. 20.06. What is the difference between the Emissions(in percent) in Peru in 1999 and the Emissions(in percent) in Zambia in 2002?
Your response must be concise. 4.92. What is the difference between the Emissions(in percent) of Portugal in 1999 and the Emissions(in percent) of Zambia in 2002?
Make the answer very short. -15.72. What is the difference between the Emissions(in percent) in East Asia (developing only) in 1999 and the Emissions(in percent) in Peru in 2003?
Make the answer very short. -46.49. What is the difference between the Emissions(in percent) of East Asia (developing only) in 1999 and the Emissions(in percent) of Portugal in 2003?
Offer a very short reply. -39.36. What is the difference between the Emissions(in percent) of East Asia (developing only) in 1999 and the Emissions(in percent) of Zambia in 2003?
Your answer should be very brief. -52.6. What is the difference between the Emissions(in percent) of Peru in 1999 and the Emissions(in percent) of Portugal in 2003?
Your answer should be compact. 20.84. What is the difference between the Emissions(in percent) in Peru in 1999 and the Emissions(in percent) in Zambia in 2003?
Give a very brief answer. 7.6. What is the difference between the Emissions(in percent) of Portugal in 1999 and the Emissions(in percent) of Zambia in 2003?
Offer a terse response. -13.04. What is the difference between the Emissions(in percent) of East Asia (developing only) in 2000 and the Emissions(in percent) of Peru in 2001?
Offer a very short reply. -49.16. What is the difference between the Emissions(in percent) in East Asia (developing only) in 2000 and the Emissions(in percent) in Portugal in 2001?
Ensure brevity in your answer.  -39.13. What is the difference between the Emissions(in percent) of East Asia (developing only) in 2000 and the Emissions(in percent) of Zambia in 2001?
Keep it short and to the point. -53.45. What is the difference between the Emissions(in percent) of Peru in 2000 and the Emissions(in percent) of Portugal in 2001?
Provide a succinct answer. 12.18. What is the difference between the Emissions(in percent) of Peru in 2000 and the Emissions(in percent) of Zambia in 2001?
Provide a succinct answer. -2.13. What is the difference between the Emissions(in percent) of Portugal in 2000 and the Emissions(in percent) of Zambia in 2001?
Provide a succinct answer. -17.06. What is the difference between the Emissions(in percent) in East Asia (developing only) in 2000 and the Emissions(in percent) in Peru in 2002?
Your answer should be compact. -46.08. What is the difference between the Emissions(in percent) in East Asia (developing only) in 2000 and the Emissions(in percent) in Portugal in 2002?
Give a very brief answer. -38.43. What is the difference between the Emissions(in percent) of East Asia (developing only) in 2000 and the Emissions(in percent) of Zambia in 2002?
Offer a terse response. -53.56. What is the difference between the Emissions(in percent) of Peru in 2000 and the Emissions(in percent) of Portugal in 2002?
Make the answer very short. 12.89. What is the difference between the Emissions(in percent) of Peru in 2000 and the Emissions(in percent) of Zambia in 2002?
Provide a short and direct response. -2.25. What is the difference between the Emissions(in percent) of Portugal in 2000 and the Emissions(in percent) of Zambia in 2002?
Your answer should be compact. -17.17. What is the difference between the Emissions(in percent) in East Asia (developing only) in 2000 and the Emissions(in percent) in Peru in 2003?
Offer a very short reply. -44.77. What is the difference between the Emissions(in percent) in East Asia (developing only) in 2000 and the Emissions(in percent) in Portugal in 2003?
Provide a succinct answer. -37.64. What is the difference between the Emissions(in percent) in East Asia (developing only) in 2000 and the Emissions(in percent) in Zambia in 2003?
Offer a terse response. -50.88. What is the difference between the Emissions(in percent) of Peru in 2000 and the Emissions(in percent) of Portugal in 2003?
Your answer should be compact. 13.67. What is the difference between the Emissions(in percent) of Peru in 2000 and the Emissions(in percent) of Zambia in 2003?
Your answer should be very brief. 0.43. What is the difference between the Emissions(in percent) of Portugal in 2000 and the Emissions(in percent) of Zambia in 2003?
Your answer should be very brief. -14.49. What is the difference between the Emissions(in percent) of East Asia (developing only) in 2001 and the Emissions(in percent) of Peru in 2002?
Give a very brief answer. -46.61. What is the difference between the Emissions(in percent) of East Asia (developing only) in 2001 and the Emissions(in percent) of Portugal in 2002?
Your answer should be compact. -38.96. What is the difference between the Emissions(in percent) in East Asia (developing only) in 2001 and the Emissions(in percent) in Zambia in 2002?
Your response must be concise. -54.1. What is the difference between the Emissions(in percent) of Peru in 2001 and the Emissions(in percent) of Portugal in 2002?
Ensure brevity in your answer.  10.73. What is the difference between the Emissions(in percent) of Peru in 2001 and the Emissions(in percent) of Zambia in 2002?
Keep it short and to the point. -4.41. What is the difference between the Emissions(in percent) in Portugal in 2001 and the Emissions(in percent) in Zambia in 2002?
Provide a short and direct response. -14.44. What is the difference between the Emissions(in percent) of East Asia (developing only) in 2001 and the Emissions(in percent) of Peru in 2003?
Keep it short and to the point. -45.3. What is the difference between the Emissions(in percent) of East Asia (developing only) in 2001 and the Emissions(in percent) of Portugal in 2003?
Your response must be concise. -38.18. What is the difference between the Emissions(in percent) in East Asia (developing only) in 2001 and the Emissions(in percent) in Zambia in 2003?
Ensure brevity in your answer.  -51.42. What is the difference between the Emissions(in percent) in Peru in 2001 and the Emissions(in percent) in Portugal in 2003?
Provide a short and direct response. 11.52. What is the difference between the Emissions(in percent) of Peru in 2001 and the Emissions(in percent) of Zambia in 2003?
Your response must be concise. -1.73. What is the difference between the Emissions(in percent) of Portugal in 2001 and the Emissions(in percent) of Zambia in 2003?
Your answer should be compact. -11.76. What is the difference between the Emissions(in percent) in East Asia (developing only) in 2002 and the Emissions(in percent) in Peru in 2003?
Your answer should be very brief. -45.53. What is the difference between the Emissions(in percent) of East Asia (developing only) in 2002 and the Emissions(in percent) of Portugal in 2003?
Provide a short and direct response. -38.4. What is the difference between the Emissions(in percent) in East Asia (developing only) in 2002 and the Emissions(in percent) in Zambia in 2003?
Provide a short and direct response. -51.64. What is the difference between the Emissions(in percent) in Peru in 2002 and the Emissions(in percent) in Portugal in 2003?
Your answer should be compact. 8.44. What is the difference between the Emissions(in percent) of Peru in 2002 and the Emissions(in percent) of Zambia in 2003?
Provide a short and direct response. -4.81. What is the difference between the Emissions(in percent) of Portugal in 2002 and the Emissions(in percent) of Zambia in 2003?
Keep it short and to the point. -12.46. What is the average Emissions(in percent) of East Asia (developing only) per year?
Your answer should be very brief. 23.48. What is the average Emissions(in percent) of Peru per year?
Provide a succinct answer. 78.26. What is the average Emissions(in percent) of Portugal per year?
Your response must be concise. 64.53. What is the average Emissions(in percent) in Zambia per year?
Give a very brief answer. 74.46. In the year 1996, what is the difference between the Emissions(in percent) of East Asia (developing only) and Emissions(in percent) of Peru?
Your answer should be compact. -60.9. In the year 1996, what is the difference between the Emissions(in percent) in East Asia (developing only) and Emissions(in percent) in Portugal?
Offer a terse response. -44.48. In the year 1996, what is the difference between the Emissions(in percent) in East Asia (developing only) and Emissions(in percent) in Zambia?
Provide a short and direct response. -46.61. In the year 1996, what is the difference between the Emissions(in percent) in Peru and Emissions(in percent) in Portugal?
Give a very brief answer. 16.42. In the year 1996, what is the difference between the Emissions(in percent) of Peru and Emissions(in percent) of Zambia?
Your response must be concise. 14.29. In the year 1996, what is the difference between the Emissions(in percent) of Portugal and Emissions(in percent) of Zambia?
Provide a succinct answer. -2.13. In the year 1997, what is the difference between the Emissions(in percent) in East Asia (developing only) and Emissions(in percent) in Peru?
Give a very brief answer. -61.48. In the year 1997, what is the difference between the Emissions(in percent) in East Asia (developing only) and Emissions(in percent) in Portugal?
Give a very brief answer. -42.66. In the year 1997, what is the difference between the Emissions(in percent) in East Asia (developing only) and Emissions(in percent) in Zambia?
Provide a short and direct response. -48.41. In the year 1997, what is the difference between the Emissions(in percent) of Peru and Emissions(in percent) of Portugal?
Give a very brief answer. 18.83. In the year 1997, what is the difference between the Emissions(in percent) of Peru and Emissions(in percent) of Zambia?
Your answer should be very brief. 13.07. In the year 1997, what is the difference between the Emissions(in percent) of Portugal and Emissions(in percent) of Zambia?
Provide a succinct answer. -5.76. In the year 1998, what is the difference between the Emissions(in percent) in East Asia (developing only) and Emissions(in percent) in Peru?
Make the answer very short. -60. In the year 1998, what is the difference between the Emissions(in percent) of East Asia (developing only) and Emissions(in percent) of Portugal?
Ensure brevity in your answer.  -45.77. In the year 1998, what is the difference between the Emissions(in percent) in East Asia (developing only) and Emissions(in percent) in Zambia?
Ensure brevity in your answer.  -49.41. In the year 1998, what is the difference between the Emissions(in percent) of Peru and Emissions(in percent) of Portugal?
Your answer should be compact. 14.22. In the year 1998, what is the difference between the Emissions(in percent) in Peru and Emissions(in percent) in Zambia?
Provide a succinct answer. 10.59. In the year 1998, what is the difference between the Emissions(in percent) in Portugal and Emissions(in percent) in Zambia?
Make the answer very short. -3.63. In the year 1999, what is the difference between the Emissions(in percent) in East Asia (developing only) and Emissions(in percent) in Peru?
Give a very brief answer. -60.2. In the year 1999, what is the difference between the Emissions(in percent) in East Asia (developing only) and Emissions(in percent) in Portugal?
Offer a terse response. -39.56. In the year 1999, what is the difference between the Emissions(in percent) in East Asia (developing only) and Emissions(in percent) in Zambia?
Ensure brevity in your answer.  -52.78. In the year 1999, what is the difference between the Emissions(in percent) of Peru and Emissions(in percent) of Portugal?
Give a very brief answer. 20.64. In the year 1999, what is the difference between the Emissions(in percent) of Peru and Emissions(in percent) of Zambia?
Offer a terse response. 7.42. In the year 1999, what is the difference between the Emissions(in percent) of Portugal and Emissions(in percent) of Zambia?
Ensure brevity in your answer.  -13.22. In the year 2000, what is the difference between the Emissions(in percent) in East Asia (developing only) and Emissions(in percent) in Peru?
Keep it short and to the point. -51.31. In the year 2000, what is the difference between the Emissions(in percent) in East Asia (developing only) and Emissions(in percent) in Portugal?
Ensure brevity in your answer.  -36.39. In the year 2000, what is the difference between the Emissions(in percent) in East Asia (developing only) and Emissions(in percent) in Zambia?
Keep it short and to the point. -48.44. In the year 2000, what is the difference between the Emissions(in percent) of Peru and Emissions(in percent) of Portugal?
Offer a very short reply. 14.92. In the year 2000, what is the difference between the Emissions(in percent) of Peru and Emissions(in percent) of Zambia?
Your response must be concise. 2.88. In the year 2000, what is the difference between the Emissions(in percent) of Portugal and Emissions(in percent) of Zambia?
Your answer should be compact. -12.04. In the year 2001, what is the difference between the Emissions(in percent) of East Asia (developing only) and Emissions(in percent) of Peru?
Offer a terse response. -49.69. In the year 2001, what is the difference between the Emissions(in percent) in East Asia (developing only) and Emissions(in percent) in Portugal?
Offer a very short reply. -39.66. In the year 2001, what is the difference between the Emissions(in percent) of East Asia (developing only) and Emissions(in percent) of Zambia?
Your answer should be very brief. -53.98. In the year 2001, what is the difference between the Emissions(in percent) of Peru and Emissions(in percent) of Portugal?
Your answer should be very brief. 10.03. In the year 2001, what is the difference between the Emissions(in percent) of Peru and Emissions(in percent) of Zambia?
Offer a very short reply. -4.29. In the year 2001, what is the difference between the Emissions(in percent) in Portugal and Emissions(in percent) in Zambia?
Ensure brevity in your answer.  -14.32. In the year 2002, what is the difference between the Emissions(in percent) of East Asia (developing only) and Emissions(in percent) of Peru?
Your response must be concise. -46.84. In the year 2002, what is the difference between the Emissions(in percent) of East Asia (developing only) and Emissions(in percent) of Portugal?
Make the answer very short. -39.18. In the year 2002, what is the difference between the Emissions(in percent) in East Asia (developing only) and Emissions(in percent) in Zambia?
Make the answer very short. -54.32. In the year 2002, what is the difference between the Emissions(in percent) of Peru and Emissions(in percent) of Portugal?
Give a very brief answer. 7.65. In the year 2002, what is the difference between the Emissions(in percent) of Peru and Emissions(in percent) of Zambia?
Your answer should be compact. -7.49. In the year 2002, what is the difference between the Emissions(in percent) of Portugal and Emissions(in percent) of Zambia?
Offer a very short reply. -15.14. In the year 2003, what is the difference between the Emissions(in percent) in East Asia (developing only) and Emissions(in percent) in Peru?
Your answer should be very brief. -47.78. In the year 2003, what is the difference between the Emissions(in percent) in East Asia (developing only) and Emissions(in percent) in Portugal?
Give a very brief answer. -40.66. In the year 2003, what is the difference between the Emissions(in percent) of East Asia (developing only) and Emissions(in percent) of Zambia?
Make the answer very short. -53.9. In the year 2003, what is the difference between the Emissions(in percent) of Peru and Emissions(in percent) of Portugal?
Give a very brief answer. 7.13. In the year 2003, what is the difference between the Emissions(in percent) of Peru and Emissions(in percent) of Zambia?
Provide a succinct answer. -6.12. In the year 2003, what is the difference between the Emissions(in percent) in Portugal and Emissions(in percent) in Zambia?
Provide a succinct answer. -13.24. What is the ratio of the Emissions(in percent) of East Asia (developing only) in 1996 to that in 1997?
Offer a terse response. 0.93. What is the ratio of the Emissions(in percent) in Peru in 1996 to that in 1997?
Give a very brief answer. 0.97. What is the ratio of the Emissions(in percent) in Zambia in 1996 to that in 1997?
Provide a succinct answer. 0.95. What is the ratio of the Emissions(in percent) in East Asia (developing only) in 1996 to that in 1998?
Offer a very short reply. 0.94. What is the ratio of the Emissions(in percent) in Peru in 1996 to that in 1998?
Your response must be concise. 0.99. What is the ratio of the Emissions(in percent) in Zambia in 1996 to that in 1998?
Give a very brief answer. 0.94. What is the ratio of the Emissions(in percent) of East Asia (developing only) in 1996 to that in 1999?
Offer a terse response. 0.92. What is the ratio of the Emissions(in percent) of Peru in 1996 to that in 1999?
Give a very brief answer. 0.99. What is the ratio of the Emissions(in percent) of Portugal in 1996 to that in 1999?
Offer a terse response. 1.05. What is the ratio of the Emissions(in percent) of Zambia in 1996 to that in 1999?
Make the answer very short. 0.89. What is the ratio of the Emissions(in percent) in East Asia (developing only) in 1996 to that in 2000?
Provide a short and direct response. 0.86. What is the ratio of the Emissions(in percent) in Peru in 1996 to that in 2000?
Offer a terse response. 1.08. What is the ratio of the Emissions(in percent) in Portugal in 1996 to that in 2000?
Ensure brevity in your answer.  1.07. What is the ratio of the Emissions(in percent) of Zambia in 1996 to that in 2000?
Give a very brief answer. 0.93. What is the ratio of the Emissions(in percent) in East Asia (developing only) in 1996 to that in 2001?
Provide a short and direct response. 0.88. What is the ratio of the Emissions(in percent) of Peru in 1996 to that in 2001?
Your answer should be very brief. 1.11. What is the ratio of the Emissions(in percent) of Portugal in 1996 to that in 2001?
Keep it short and to the point. 1.03. What is the ratio of the Emissions(in percent) of Zambia in 1996 to that in 2001?
Your answer should be compact. 0.87. What is the ratio of the Emissions(in percent) in East Asia (developing only) in 1996 to that in 2002?
Your response must be concise. 0.88. What is the ratio of the Emissions(in percent) in Peru in 1996 to that in 2002?
Keep it short and to the point. 1.16. What is the ratio of the Emissions(in percent) of Portugal in 1996 to that in 2002?
Provide a short and direct response. 1.04. What is the ratio of the Emissions(in percent) in Zambia in 1996 to that in 2002?
Ensure brevity in your answer.  0.87. What is the ratio of the Emissions(in percent) in East Asia (developing only) in 1996 to that in 2003?
Your answer should be very brief. 0.97. What is the ratio of the Emissions(in percent) of Peru in 1996 to that in 2003?
Your answer should be compact. 1.18. What is the ratio of the Emissions(in percent) in Portugal in 1996 to that in 2003?
Offer a terse response. 1.05. What is the ratio of the Emissions(in percent) in Zambia in 1996 to that in 2003?
Your response must be concise. 0.9. What is the ratio of the Emissions(in percent) in East Asia (developing only) in 1997 to that in 1998?
Ensure brevity in your answer.  1.01. What is the ratio of the Emissions(in percent) in Peru in 1997 to that in 1998?
Provide a short and direct response. 1.02. What is the ratio of the Emissions(in percent) in Portugal in 1997 to that in 1998?
Offer a terse response. 0.96. What is the ratio of the Emissions(in percent) in Zambia in 1997 to that in 1998?
Your answer should be very brief. 0.99. What is the ratio of the Emissions(in percent) in East Asia (developing only) in 1997 to that in 1999?
Provide a short and direct response. 0.99. What is the ratio of the Emissions(in percent) of Portugal in 1997 to that in 1999?
Your answer should be compact. 1.04. What is the ratio of the Emissions(in percent) of Zambia in 1997 to that in 1999?
Keep it short and to the point. 0.94. What is the ratio of the Emissions(in percent) of East Asia (developing only) in 1997 to that in 2000?
Keep it short and to the point. 0.92. What is the ratio of the Emissions(in percent) in Peru in 1997 to that in 2000?
Ensure brevity in your answer.  1.11. What is the ratio of the Emissions(in percent) in Portugal in 1997 to that in 2000?
Your answer should be very brief. 1.07. What is the ratio of the Emissions(in percent) of Zambia in 1997 to that in 2000?
Your answer should be compact. 0.97. What is the ratio of the Emissions(in percent) of East Asia (developing only) in 1997 to that in 2001?
Ensure brevity in your answer.  0.94. What is the ratio of the Emissions(in percent) of Peru in 1997 to that in 2001?
Your response must be concise. 1.14. What is the ratio of the Emissions(in percent) in Portugal in 1997 to that in 2001?
Offer a terse response. 1.02. What is the ratio of the Emissions(in percent) of Zambia in 1997 to that in 2001?
Keep it short and to the point. 0.91. What is the ratio of the Emissions(in percent) of East Asia (developing only) in 1997 to that in 2002?
Make the answer very short. 0.95. What is the ratio of the Emissions(in percent) in Peru in 1997 to that in 2002?
Provide a short and direct response. 1.19. What is the ratio of the Emissions(in percent) in Portugal in 1997 to that in 2002?
Provide a succinct answer. 1.04. What is the ratio of the Emissions(in percent) of Zambia in 1997 to that in 2002?
Ensure brevity in your answer.  0.91. What is the ratio of the Emissions(in percent) in East Asia (developing only) in 1997 to that in 2003?
Provide a succinct answer. 1.05. What is the ratio of the Emissions(in percent) in Peru in 1997 to that in 2003?
Ensure brevity in your answer.  1.21. What is the ratio of the Emissions(in percent) of Portugal in 1997 to that in 2003?
Ensure brevity in your answer.  1.05. What is the ratio of the Emissions(in percent) in Zambia in 1997 to that in 2003?
Offer a terse response. 0.94. What is the ratio of the Emissions(in percent) in East Asia (developing only) in 1998 to that in 1999?
Make the answer very short. 0.98. What is the ratio of the Emissions(in percent) of Peru in 1998 to that in 1999?
Offer a very short reply. 0.99. What is the ratio of the Emissions(in percent) in Portugal in 1998 to that in 1999?
Provide a short and direct response. 1.09. What is the ratio of the Emissions(in percent) in Zambia in 1998 to that in 1999?
Provide a short and direct response. 0.95. What is the ratio of the Emissions(in percent) in East Asia (developing only) in 1998 to that in 2000?
Offer a very short reply. 0.91. What is the ratio of the Emissions(in percent) in Peru in 1998 to that in 2000?
Provide a short and direct response. 1.08. What is the ratio of the Emissions(in percent) in Portugal in 1998 to that in 2000?
Keep it short and to the point. 1.12. What is the ratio of the Emissions(in percent) of Zambia in 1998 to that in 2000?
Ensure brevity in your answer.  0.98. What is the ratio of the Emissions(in percent) of East Asia (developing only) in 1998 to that in 2001?
Keep it short and to the point. 0.93. What is the ratio of the Emissions(in percent) in Peru in 1998 to that in 2001?
Keep it short and to the point. 1.12. What is the ratio of the Emissions(in percent) of Portugal in 1998 to that in 2001?
Give a very brief answer. 1.07. What is the ratio of the Emissions(in percent) of Zambia in 1998 to that in 2001?
Your answer should be compact. 0.92. What is the ratio of the Emissions(in percent) in East Asia (developing only) in 1998 to that in 2002?
Provide a succinct answer. 0.94. What is the ratio of the Emissions(in percent) in Peru in 1998 to that in 2002?
Provide a short and direct response. 1.16. What is the ratio of the Emissions(in percent) of Portugal in 1998 to that in 2002?
Offer a very short reply. 1.08. What is the ratio of the Emissions(in percent) of Zambia in 1998 to that in 2002?
Your response must be concise. 0.92. What is the ratio of the Emissions(in percent) in East Asia (developing only) in 1998 to that in 2003?
Offer a very short reply. 1.04. What is the ratio of the Emissions(in percent) in Peru in 1998 to that in 2003?
Make the answer very short. 1.19. What is the ratio of the Emissions(in percent) of Portugal in 1998 to that in 2003?
Offer a very short reply. 1.09. What is the ratio of the Emissions(in percent) of Zambia in 1998 to that in 2003?
Keep it short and to the point. 0.95. What is the ratio of the Emissions(in percent) in East Asia (developing only) in 1999 to that in 2000?
Provide a short and direct response. 0.93. What is the ratio of the Emissions(in percent) of Peru in 1999 to that in 2000?
Your answer should be compact. 1.09. What is the ratio of the Emissions(in percent) in Portugal in 1999 to that in 2000?
Ensure brevity in your answer.  1.02. What is the ratio of the Emissions(in percent) in Zambia in 1999 to that in 2000?
Make the answer very short. 1.04. What is the ratio of the Emissions(in percent) of Peru in 1999 to that in 2001?
Keep it short and to the point. 1.13. What is the ratio of the Emissions(in percent) in Portugal in 1999 to that in 2001?
Make the answer very short. 0.98. What is the ratio of the Emissions(in percent) in Zambia in 1999 to that in 2001?
Provide a short and direct response. 0.97. What is the ratio of the Emissions(in percent) of East Asia (developing only) in 1999 to that in 2002?
Keep it short and to the point. 0.96. What is the ratio of the Emissions(in percent) in Peru in 1999 to that in 2002?
Ensure brevity in your answer.  1.17. What is the ratio of the Emissions(in percent) of Portugal in 1999 to that in 2002?
Your answer should be compact. 0.99. What is the ratio of the Emissions(in percent) of Zambia in 1999 to that in 2002?
Offer a terse response. 0.97. What is the ratio of the Emissions(in percent) of East Asia (developing only) in 1999 to that in 2003?
Offer a very short reply. 1.06. What is the ratio of the Emissions(in percent) of Peru in 1999 to that in 2003?
Give a very brief answer. 1.2. What is the ratio of the Emissions(in percent) of Portugal in 1999 to that in 2003?
Offer a terse response. 1. What is the ratio of the Emissions(in percent) in Zambia in 1999 to that in 2003?
Provide a short and direct response. 1. What is the ratio of the Emissions(in percent) in East Asia (developing only) in 2000 to that in 2001?
Your response must be concise. 1.02. What is the ratio of the Emissions(in percent) of Portugal in 2000 to that in 2001?
Keep it short and to the point. 0.96. What is the ratio of the Emissions(in percent) of Zambia in 2000 to that in 2001?
Offer a very short reply. 0.94. What is the ratio of the Emissions(in percent) of East Asia (developing only) in 2000 to that in 2002?
Provide a succinct answer. 1.03. What is the ratio of the Emissions(in percent) of Peru in 2000 to that in 2002?
Keep it short and to the point. 1.07. What is the ratio of the Emissions(in percent) of Zambia in 2000 to that in 2002?
Your answer should be very brief. 0.93. What is the ratio of the Emissions(in percent) in East Asia (developing only) in 2000 to that in 2003?
Keep it short and to the point. 1.14. What is the ratio of the Emissions(in percent) in Peru in 2000 to that in 2003?
Your answer should be very brief. 1.09. What is the ratio of the Emissions(in percent) in Portugal in 2000 to that in 2003?
Your answer should be very brief. 0.98. What is the ratio of the Emissions(in percent) of Zambia in 2000 to that in 2003?
Your answer should be very brief. 0.97. What is the ratio of the Emissions(in percent) in East Asia (developing only) in 2001 to that in 2002?
Your answer should be compact. 1.01. What is the ratio of the Emissions(in percent) in Peru in 2001 to that in 2002?
Ensure brevity in your answer.  1.04. What is the ratio of the Emissions(in percent) of Portugal in 2001 to that in 2002?
Offer a very short reply. 1.01. What is the ratio of the Emissions(in percent) of East Asia (developing only) in 2001 to that in 2003?
Your answer should be very brief. 1.11. What is the ratio of the Emissions(in percent) of Peru in 2001 to that in 2003?
Make the answer very short. 1.06. What is the ratio of the Emissions(in percent) of Portugal in 2001 to that in 2003?
Provide a succinct answer. 1.02. What is the ratio of the Emissions(in percent) in Zambia in 2001 to that in 2003?
Make the answer very short. 1.03. What is the ratio of the Emissions(in percent) of East Asia (developing only) in 2002 to that in 2003?
Your response must be concise. 1.1. What is the ratio of the Emissions(in percent) in Peru in 2002 to that in 2003?
Make the answer very short. 1.02. What is the ratio of the Emissions(in percent) of Portugal in 2002 to that in 2003?
Offer a terse response. 1.01. What is the ratio of the Emissions(in percent) of Zambia in 2002 to that in 2003?
Ensure brevity in your answer.  1.04. What is the difference between the highest and the second highest Emissions(in percent) in East Asia (developing only)?
Provide a succinct answer. 0.53. What is the difference between the highest and the second highest Emissions(in percent) of Peru?
Your answer should be very brief. 1.01. What is the difference between the highest and the second highest Emissions(in percent) in Portugal?
Your response must be concise. 2.68. What is the difference between the highest and the second highest Emissions(in percent) of Zambia?
Your response must be concise. 0.12. What is the difference between the highest and the lowest Emissions(in percent) in East Asia (developing only)?
Offer a very short reply. 3.58. What is the difference between the highest and the lowest Emissions(in percent) in Peru?
Ensure brevity in your answer.  14.72. What is the difference between the highest and the lowest Emissions(in percent) of Portugal?
Offer a very short reply. 7.19. What is the difference between the highest and the lowest Emissions(in percent) of Zambia?
Ensure brevity in your answer.  10.54. 